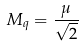<formula> <loc_0><loc_0><loc_500><loc_500>M _ { q } = \frac { \mu } { \sqrt { 2 } }</formula> 